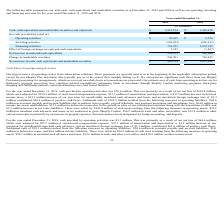According to Shopify's financial document, What is Shopify's largest source of operating cash from? subscription solutions. The document states: "Our largest source of operating cash is from subscription solutions. These payments are typically paid to us at the beginning of the applicable subscr..." Also, What is Shopify's primary uses of cash from its operating activities? third-party payment processing fees, employee-related expenditures, advancing funds to merchants through Shopify Capital, marketing programs, third-party shipping and fulfillment partners, outsourced hosting costs, and leased facilities. The document states: "ry uses of cash from operating activities are for third-party payment processing fees, employee-related expenditures, advancing funds to merchants thr..." Also, How much is the cash provided by operating activities for year ended December 31, 2019? According to the financial document, $70,615 (in thousands). The relevant text states: "Operating activities $ 70,615 $ 9,324..." Also, can you calculate: What is the average net cash provided by operating activities for 2018 and 2019? To answer this question, I need to perform calculations using the financial data. The calculation is: ($70,615+$9,324)/2, which equals 39969.5 (in thousands). This is based on the information: "Operating activities $ 70,615 $ 9,324 Operating activities $ 70,615 $ 9,324..." The key data points involved are: 70,615, 9,324. Also, can you calculate: What is the average net cash provided by financing activities for 2018 and 2019? To answer this question, I need to perform calculations using the financial data. The calculation is: (736,351+1,072,182)/2, which equals 904266.5 (in thousands). This is based on the information: "Financing activities 736,351 1,072,182 Financing activities 736,351 1,072,182..." The key data points involved are: 1,072,182, 736,351. Also, can you calculate: What is the change in net increase in cash and cash equivalents for year ended 2018 and 2019 ? Based on the calculation: 239,233-269,006, the result is -29773 (in thousands). This is based on the information: "Net increase in cash and cash equivalents 239,233 269,006 Net increase in cash and cash equivalents 239,233 269,006..." The key data points involved are: 239,233, 269,006. 